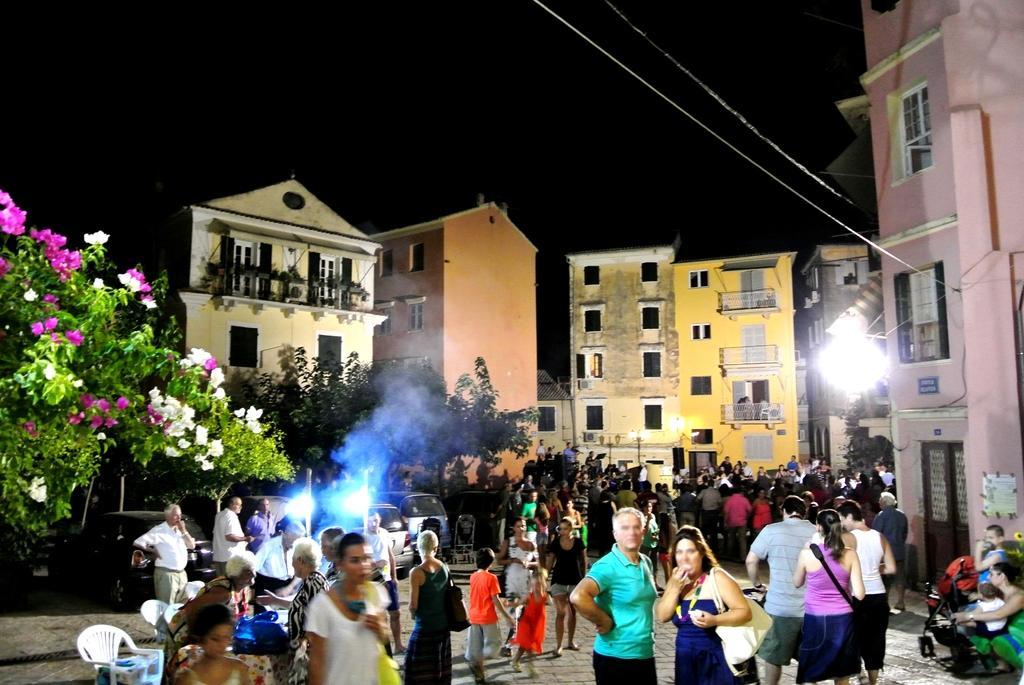Could you give a brief overview of what you see in this image? Few people are sitting and few people are standing. We can see lights,chairs and objects on the table. Background we can see people,trees,flowers and windows. 